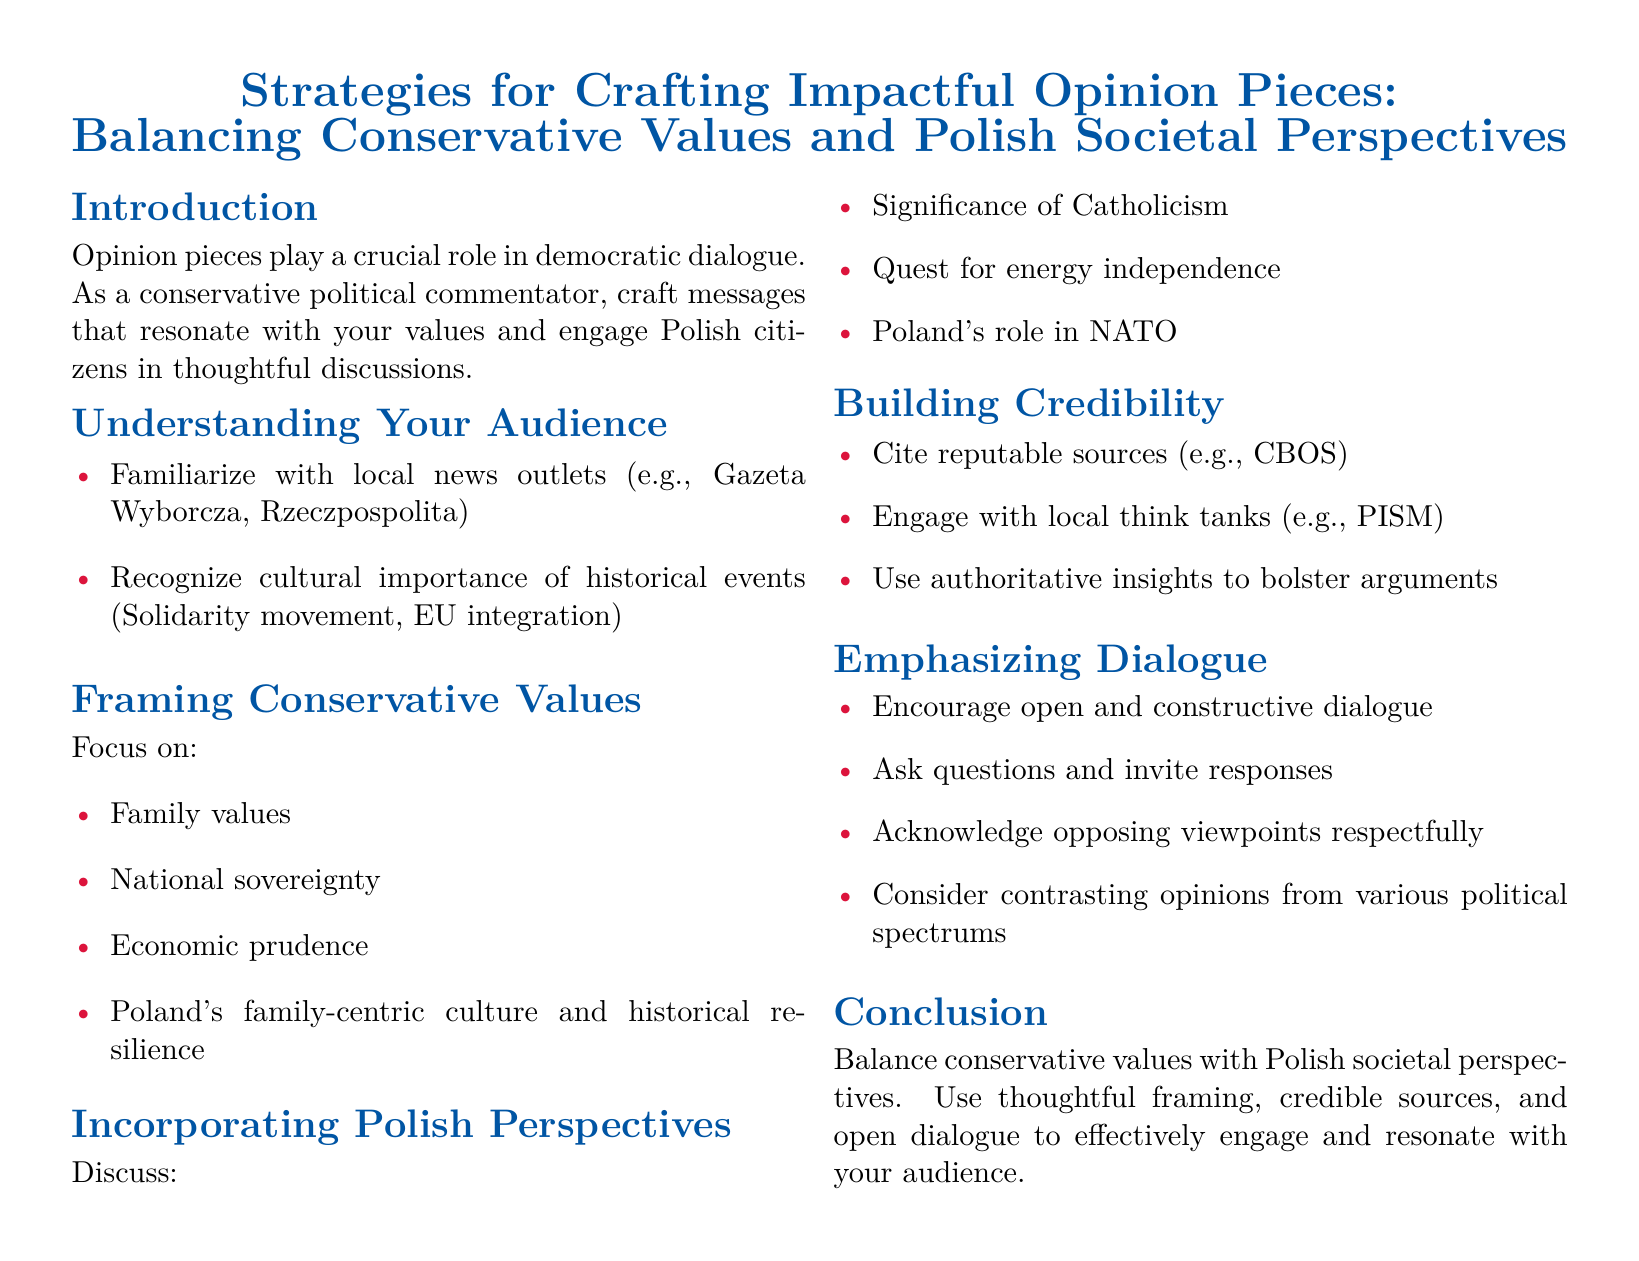What is the main purpose of opinion pieces? The introduction states that opinion pieces play a crucial role in democratic dialogue.
Answer: Democratic dialogue Which local news outlet is mentioned first? The document lists Gazeta Wyborcza as the first local news outlet.
Answer: Gazeta Wyborcza What cultural aspect is highlighted in the document? The document emphasizes the cultural importance of the historical events such as the Solidarity movement and EU integration.
Answer: Historical events What type of values does the guide suggest framing around? The guide suggests framing around family values.
Answer: Family values Which source should be cited for credibility? The document recommends citing reputable sources like CBOS for credibility.
Answer: CBOS What is one of the methods suggested for encouraging dialogue? The guide suggests asking questions and inviting responses to encourage dialogue.
Answer: Ask questions Which think tank is mentioned in the document? The document mentions PISM as a local think tank to engage with.
Answer: PISM What is the color associated with the title? The title is associated with the color conservative blue.
Answer: Conservative blue How many sections are in the document? The document has six main sections listed.
Answer: Six 